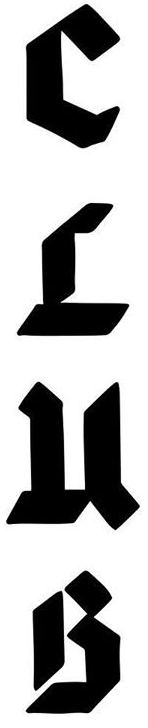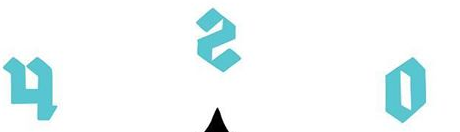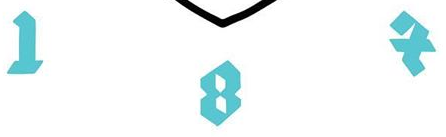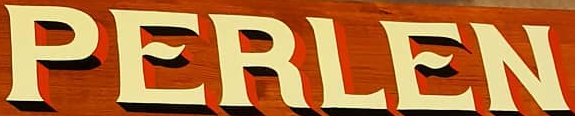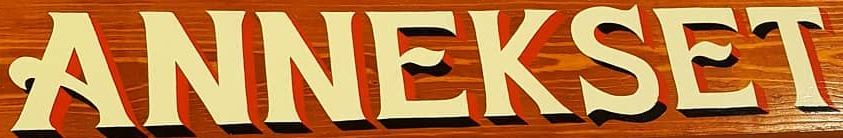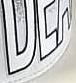What words are shown in these images in order, separated by a semicolon? CLuB; osh; IBX; PERLEN; ANNEKSET; ### 